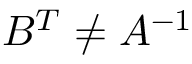Convert formula to latex. <formula><loc_0><loc_0><loc_500><loc_500>B ^ { T } \neq A ^ { - 1 }</formula> 